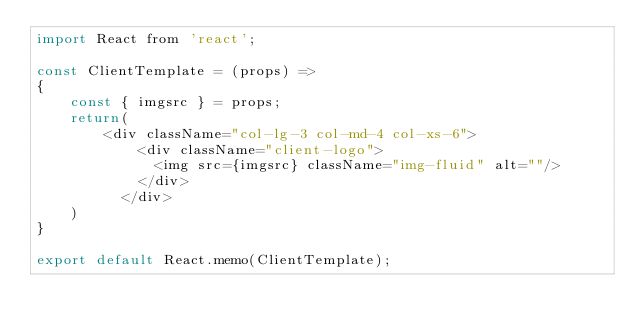<code> <loc_0><loc_0><loc_500><loc_500><_JavaScript_>import React from 'react';

const ClientTemplate = (props) =>
{
    const { imgsrc } = props;
    return(
        <div className="col-lg-3 col-md-4 col-xs-6">
            <div className="client-logo">
              <img src={imgsrc} className="img-fluid" alt=""/>
            </div>
          </div>
    )
}

export default React.memo(ClientTemplate);</code> 